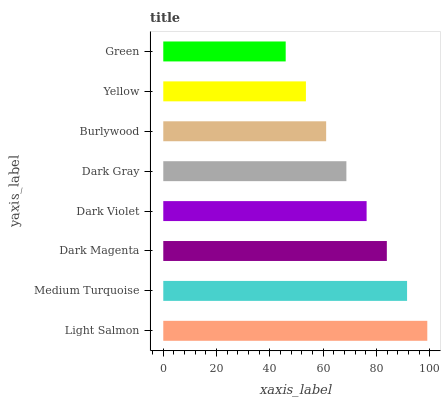Is Green the minimum?
Answer yes or no. Yes. Is Light Salmon the maximum?
Answer yes or no. Yes. Is Medium Turquoise the minimum?
Answer yes or no. No. Is Medium Turquoise the maximum?
Answer yes or no. No. Is Light Salmon greater than Medium Turquoise?
Answer yes or no. Yes. Is Medium Turquoise less than Light Salmon?
Answer yes or no. Yes. Is Medium Turquoise greater than Light Salmon?
Answer yes or no. No. Is Light Salmon less than Medium Turquoise?
Answer yes or no. No. Is Dark Violet the high median?
Answer yes or no. Yes. Is Dark Gray the low median?
Answer yes or no. Yes. Is Dark Magenta the high median?
Answer yes or no. No. Is Yellow the low median?
Answer yes or no. No. 